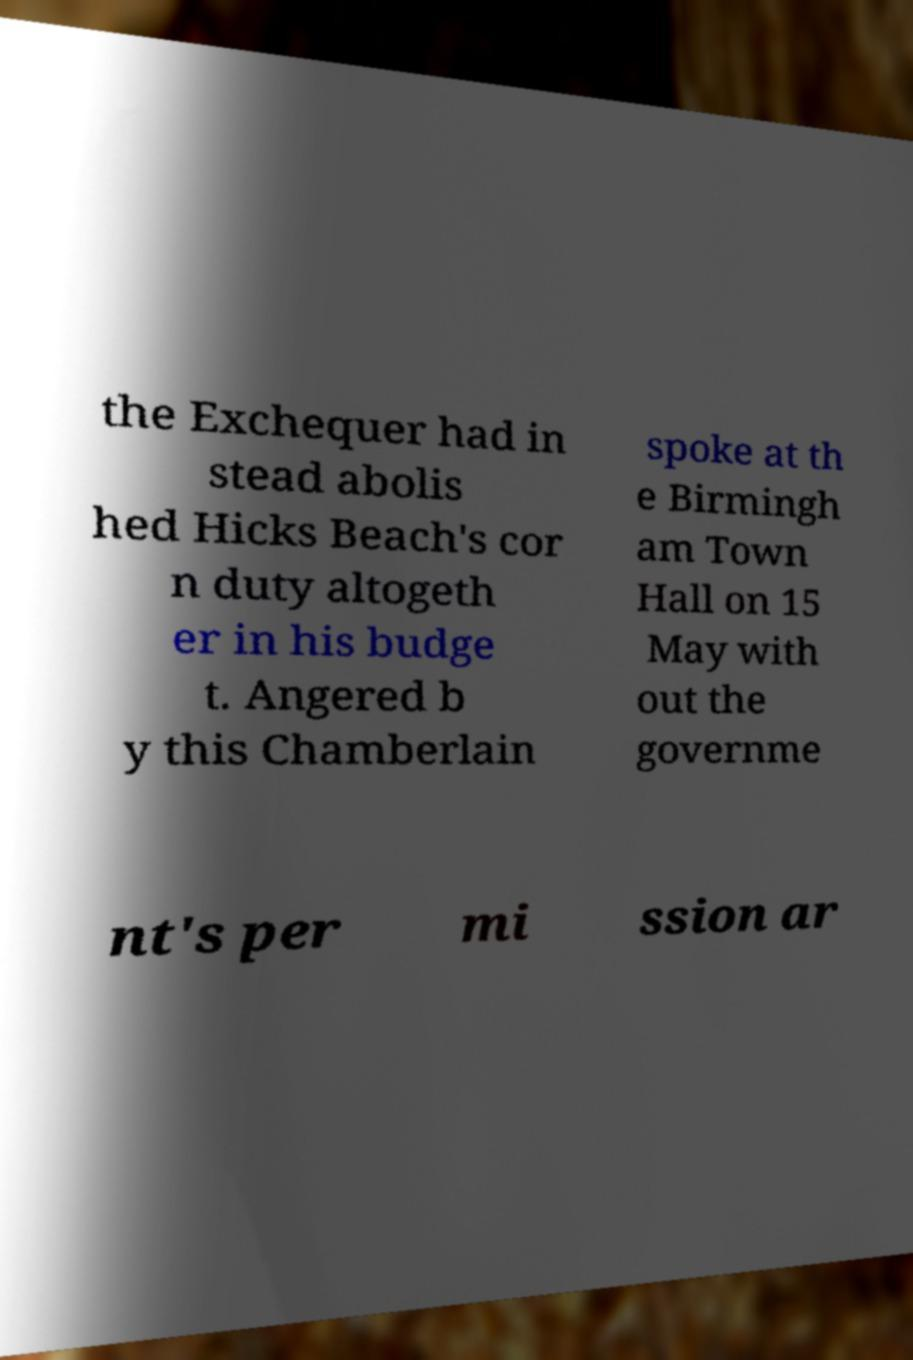There's text embedded in this image that I need extracted. Can you transcribe it verbatim? the Exchequer had in stead abolis hed Hicks Beach's cor n duty altogeth er in his budge t. Angered b y this Chamberlain spoke at th e Birmingh am Town Hall on 15 May with out the governme nt's per mi ssion ar 